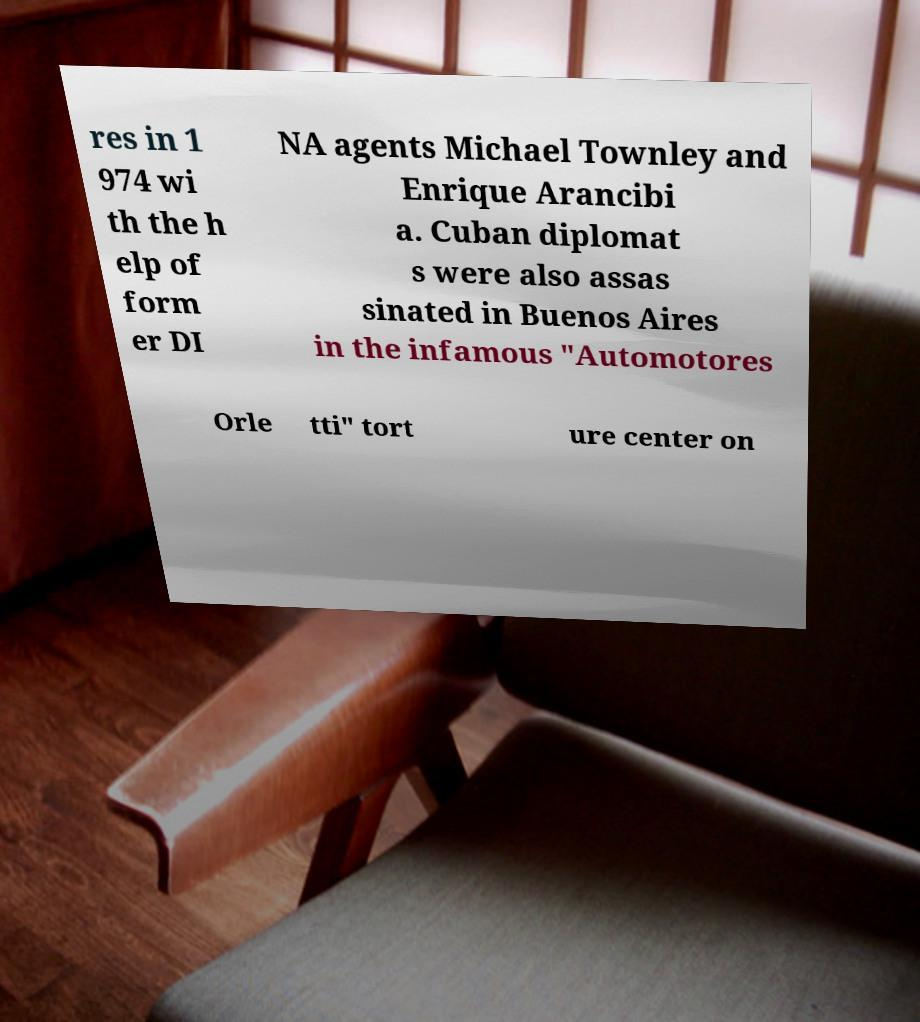Could you assist in decoding the text presented in this image and type it out clearly? res in 1 974 wi th the h elp of form er DI NA agents Michael Townley and Enrique Arancibi a. Cuban diplomat s were also assas sinated in Buenos Aires in the infamous "Automotores Orle tti" tort ure center on 